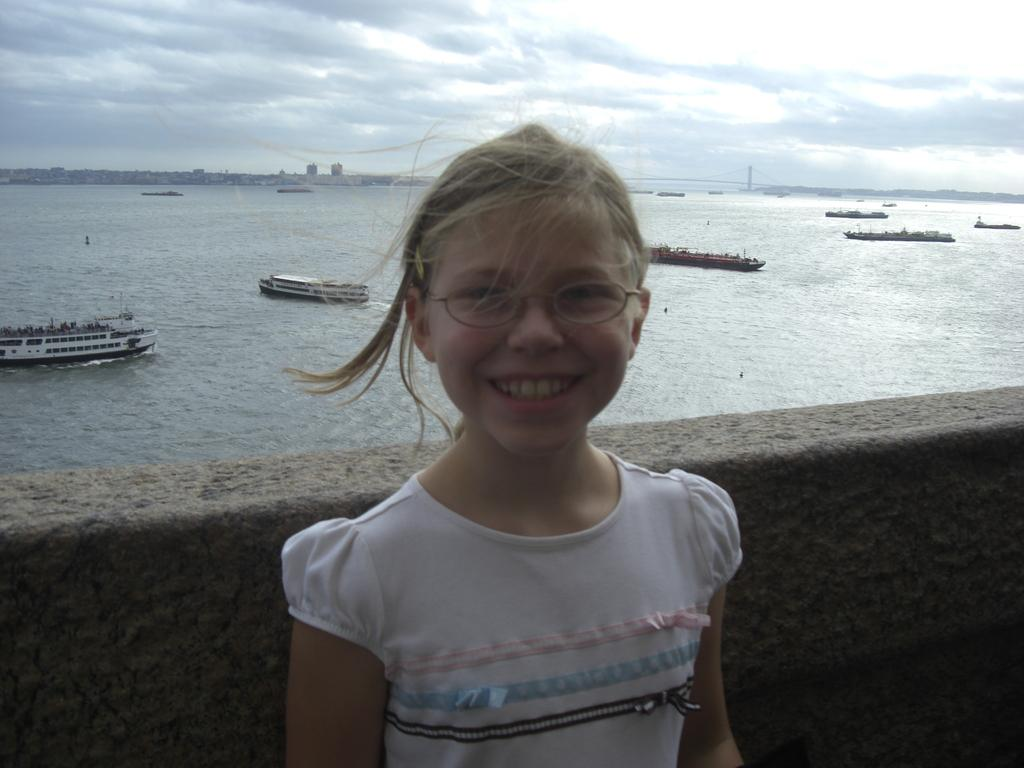Who is in the image? There is a girl in the image. What is the girl doing in the image? The girl is standing in front of a wall and smiling. What can be seen in the background of the image? There is an ocean visible in the image, with ships in it. The sky is also visible, and clouds are present in the sky. What type of balls can be seen rolling on the ground in the image? There are no balls present in the image. What substance is the girl holding in her hand in the image? The image does not show the girl holding any substance in her hand. 